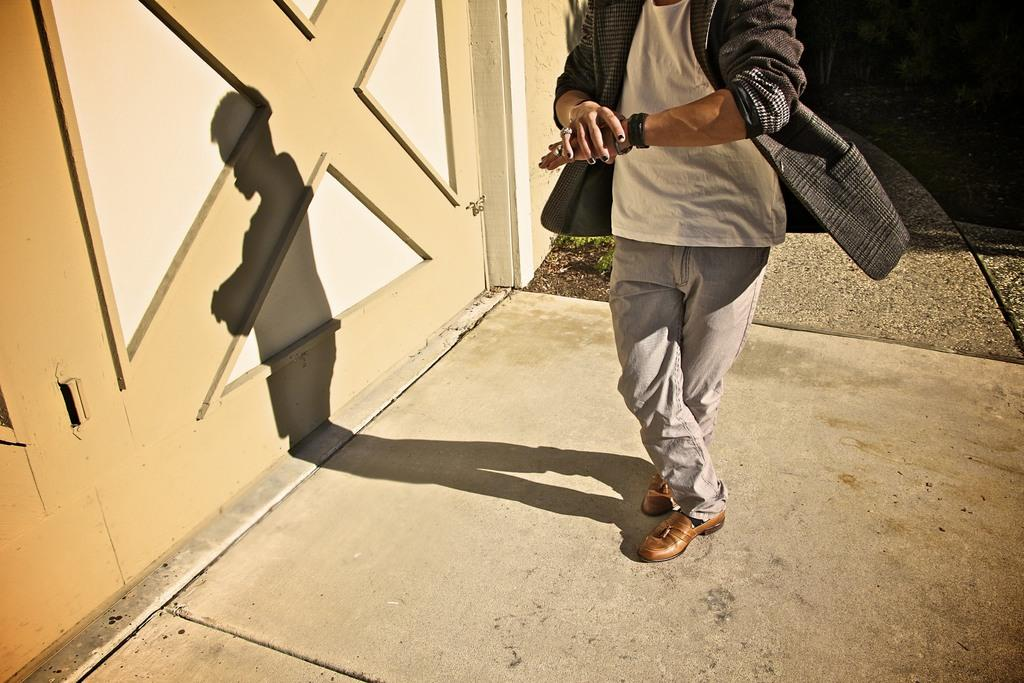Where was the image taken? The image was taken outdoors. What is at the bottom of the image? There is a floor at the bottom of the image. What can be seen on the left side of the image? There is a wall on the left side of the image. Who is in the middle of the image? There is a man in the middle of the image. What type of pig can be seen shaking hands with the man in the image? There is no pig present in the image, nor is there any indication of a handshake. 